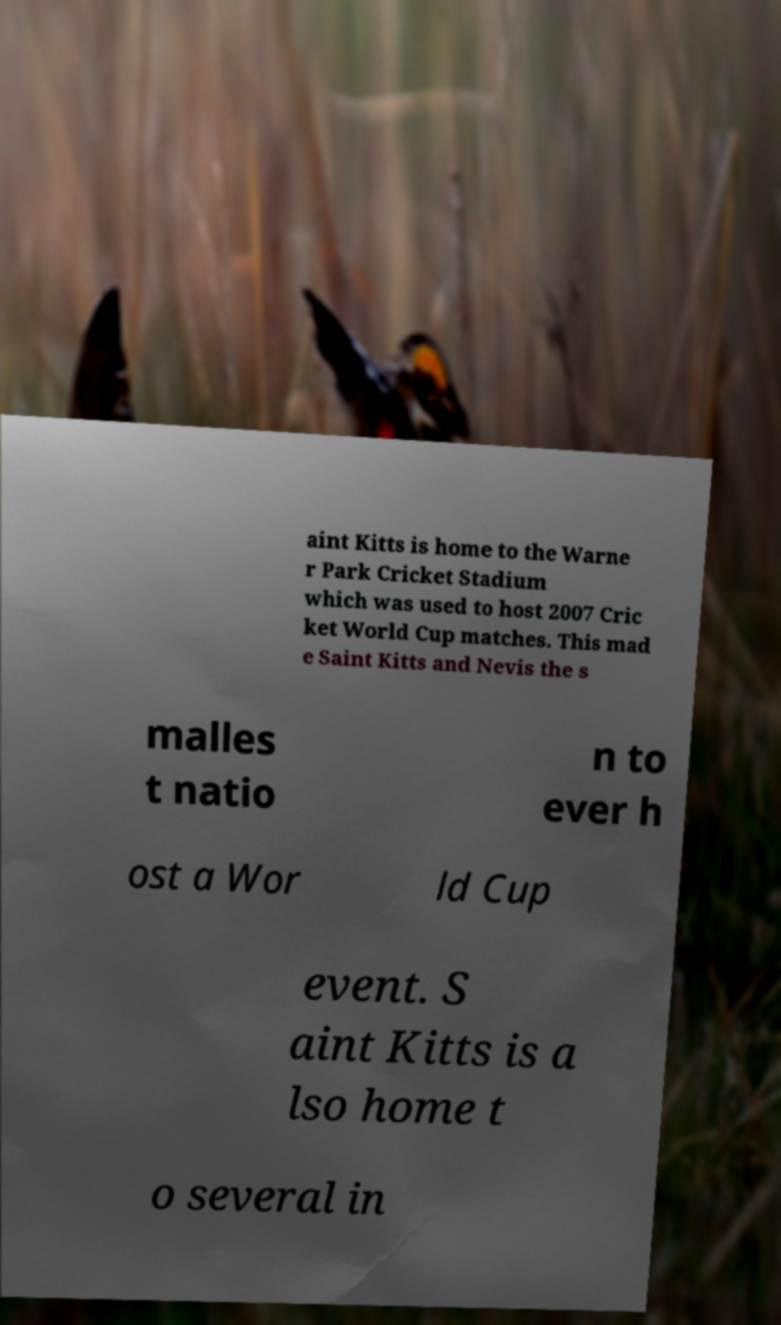Could you extract and type out the text from this image? aint Kitts is home to the Warne r Park Cricket Stadium which was used to host 2007 Cric ket World Cup matches. This mad e Saint Kitts and Nevis the s malles t natio n to ever h ost a Wor ld Cup event. S aint Kitts is a lso home t o several in 